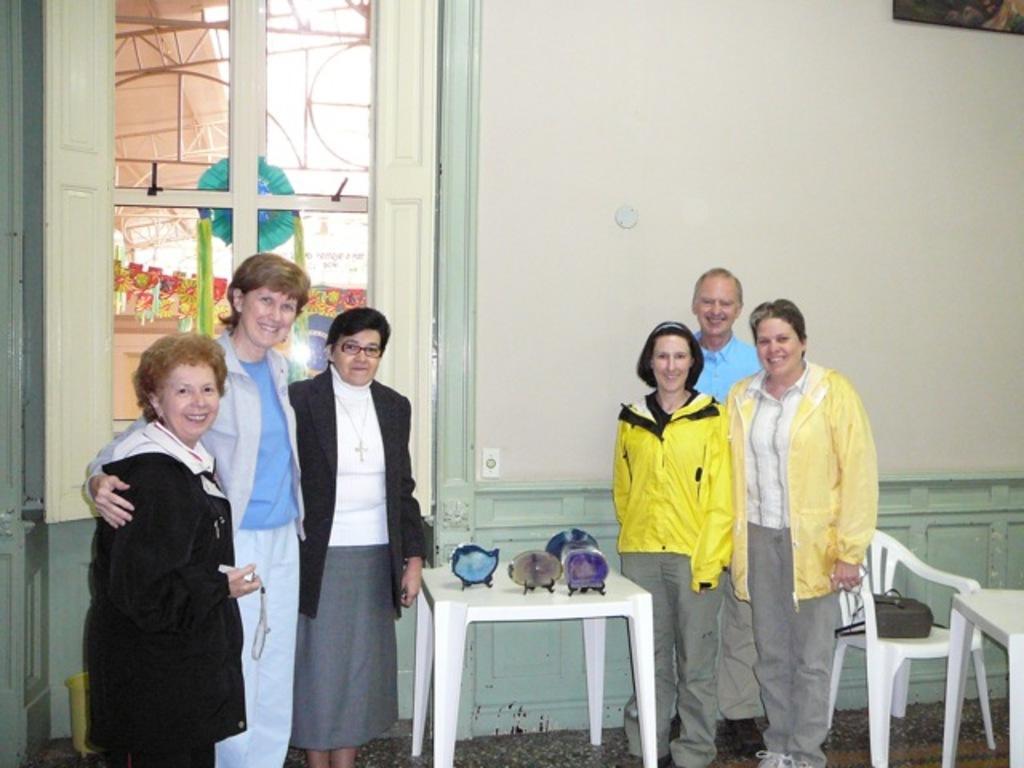Describe this image in one or two sentences. In this image, we can see few people are standing. They are watching and smiling. Here we can see tables, chair and a few objects. Background we can see wall, glass window, painting. Through the glass window, we can see decorative objects and rod. 